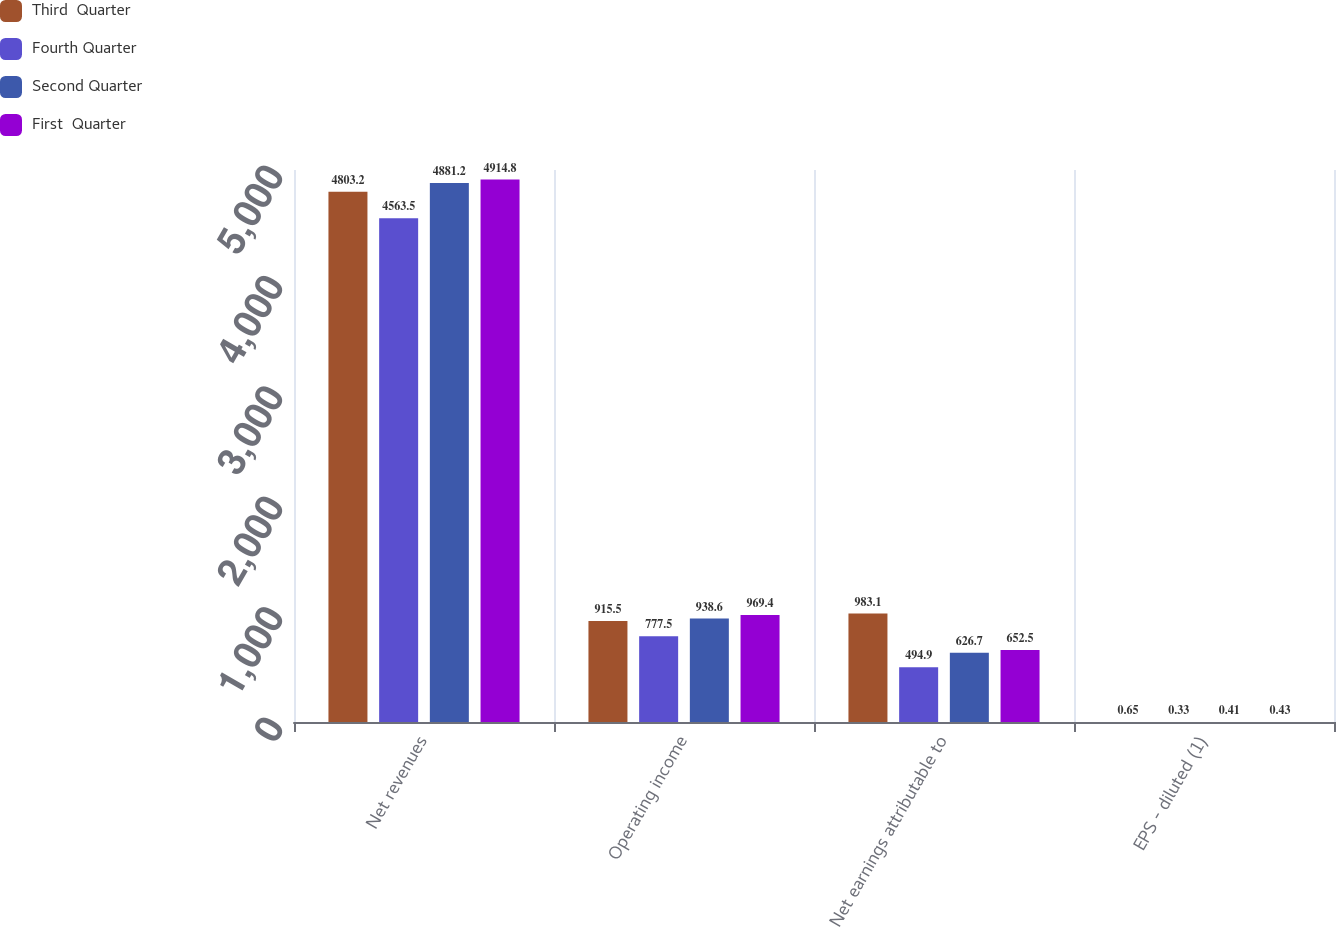Convert chart. <chart><loc_0><loc_0><loc_500><loc_500><stacked_bar_chart><ecel><fcel>Net revenues<fcel>Operating income<fcel>Net earnings attributable to<fcel>EPS - diluted (1)<nl><fcel>Third  Quarter<fcel>4803.2<fcel>915.5<fcel>983.1<fcel>0.65<nl><fcel>Fourth Quarter<fcel>4563.5<fcel>777.5<fcel>494.9<fcel>0.33<nl><fcel>Second Quarter<fcel>4881.2<fcel>938.6<fcel>626.7<fcel>0.41<nl><fcel>First  Quarter<fcel>4914.8<fcel>969.4<fcel>652.5<fcel>0.43<nl></chart> 